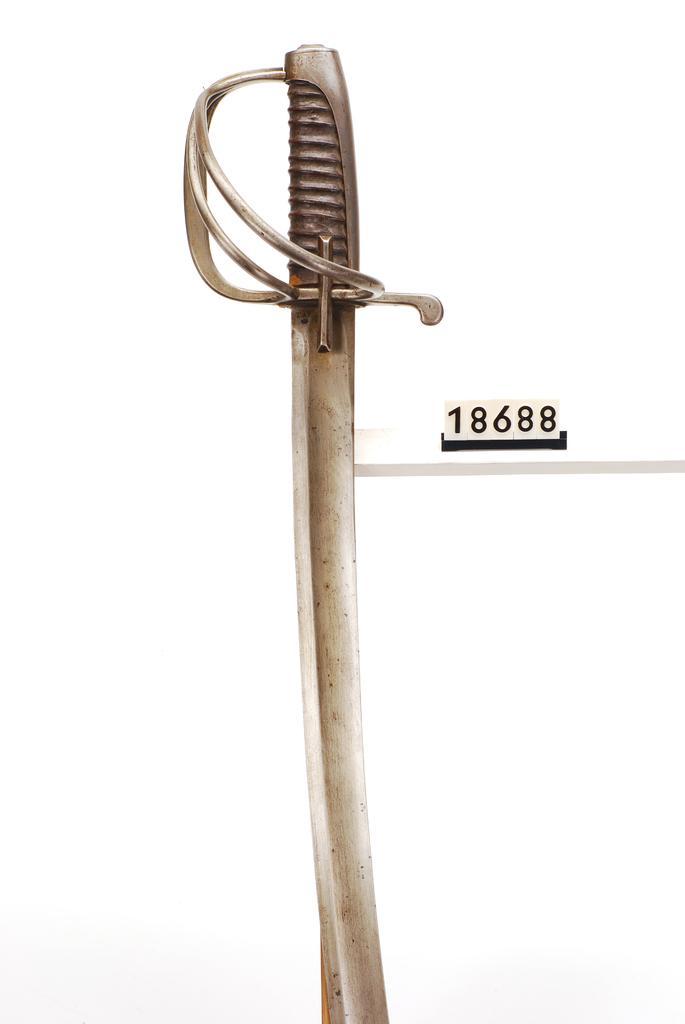Can you describe this image briefly? In this image I can see a sword. 